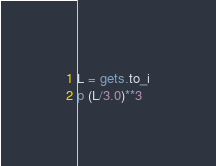<code> <loc_0><loc_0><loc_500><loc_500><_Ruby_>L = gets.to_i
p (L/3.0)**3</code> 